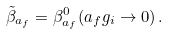<formula> <loc_0><loc_0><loc_500><loc_500>\tilde { \beta } _ { a _ { f } } = \beta _ { a _ { f } } ^ { 0 } ( a _ { f } g _ { i } \to 0 ) \, .</formula> 